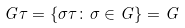<formula> <loc_0><loc_0><loc_500><loc_500>G \tau = \{ \sigma \tau \colon \sigma \in G \} = G</formula> 